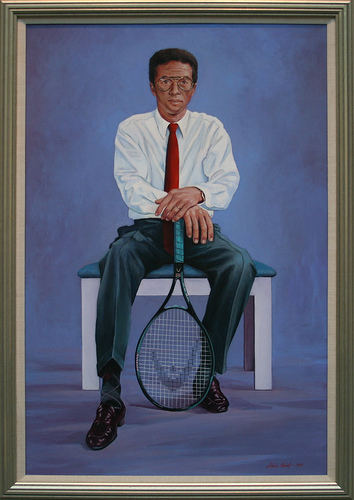Please provide the bounding box coordinate of the region this sentence describes: a man is wearing eye glasses. The area where the man is wearing eyeglasses is roughly within coordinates [0.45, 0.14, 0.53, 0.18]. 